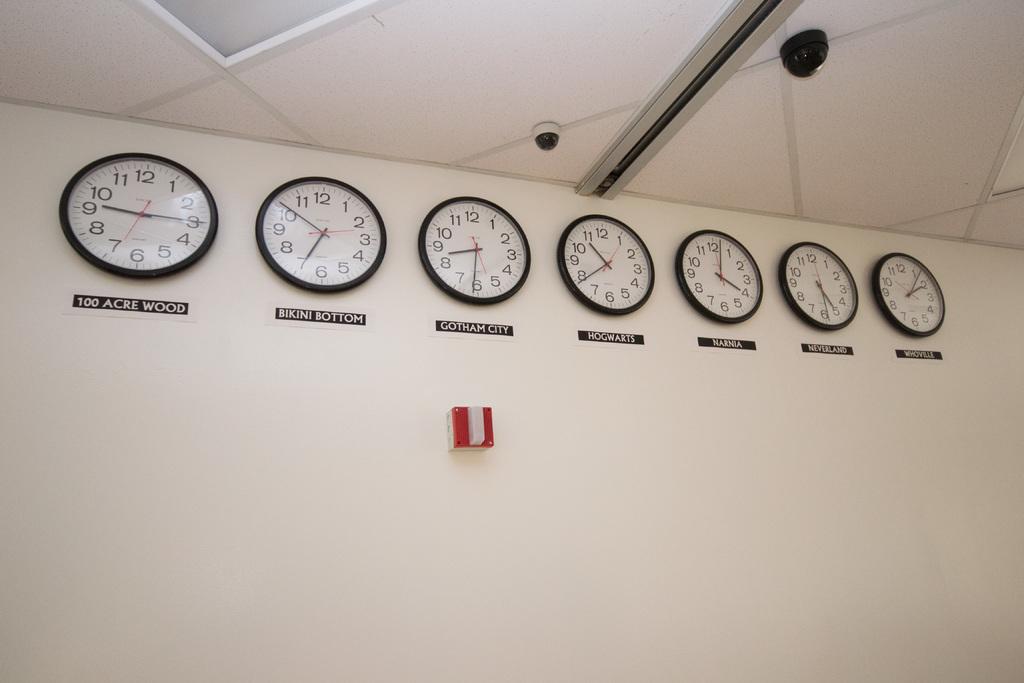What location is the clock on the far right for?
Keep it short and to the point. Whoville. 